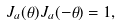Convert formula to latex. <formula><loc_0><loc_0><loc_500><loc_500>J _ { a } ( \theta ) J _ { a } ( - \theta ) = 1 ,</formula> 